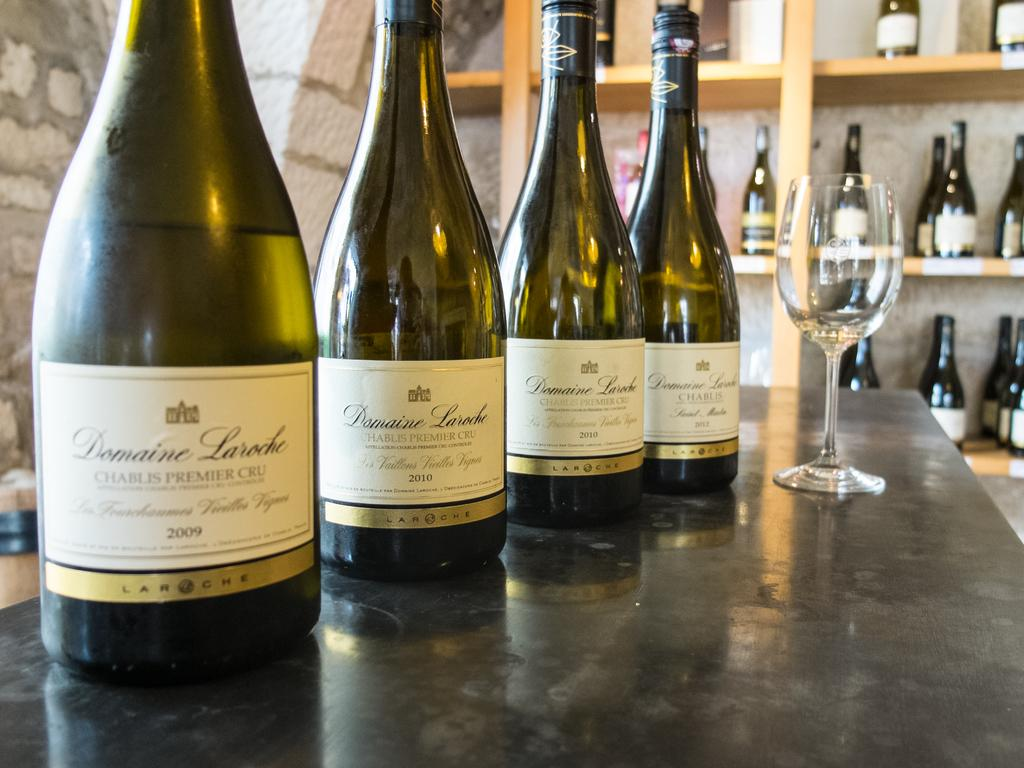<image>
Relay a brief, clear account of the picture shown. Four bottles of Domaine Laroche wine sit on a bar, along with an empty wine glass. 